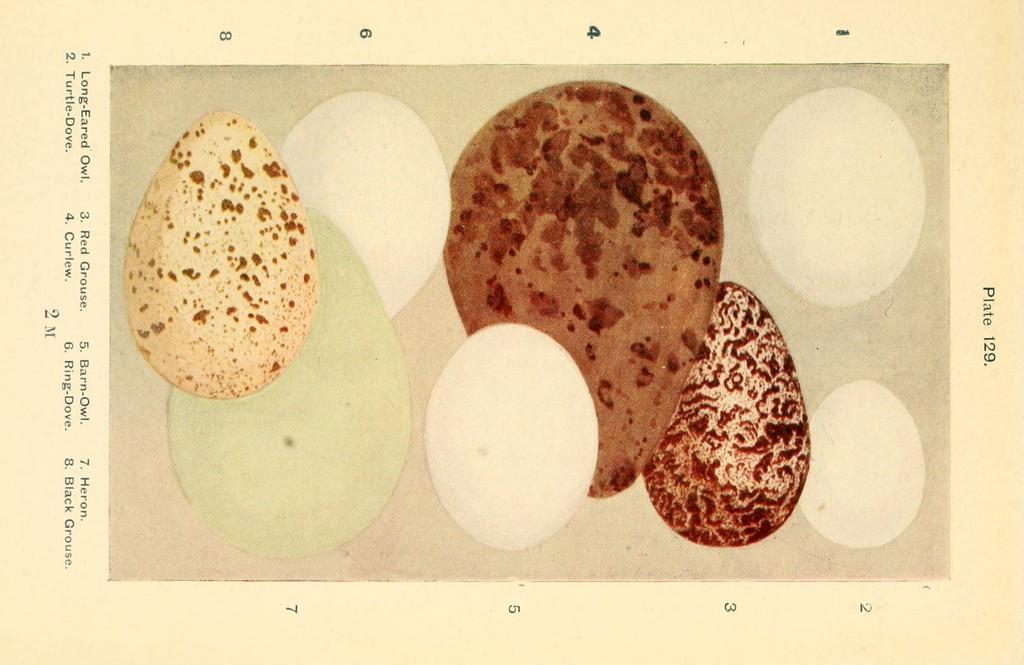Can you describe this image briefly? This picture is consists of types of eggs poster in the image. 